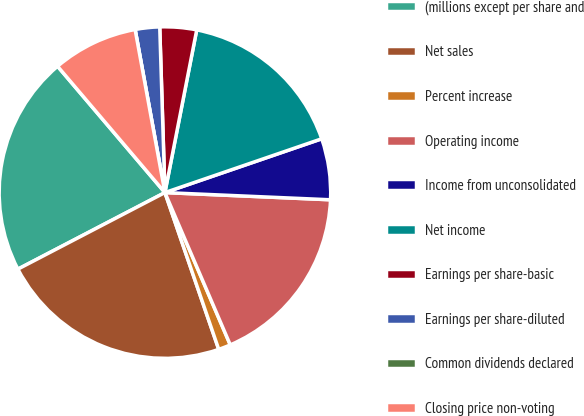Convert chart to OTSL. <chart><loc_0><loc_0><loc_500><loc_500><pie_chart><fcel>(millions except per share and<fcel>Net sales<fcel>Percent increase<fcel>Operating income<fcel>Income from unconsolidated<fcel>Net income<fcel>Earnings per share-basic<fcel>Earnings per share-diluted<fcel>Common dividends declared<fcel>Closing price non-voting<nl><fcel>21.42%<fcel>22.61%<fcel>1.19%<fcel>17.85%<fcel>5.95%<fcel>16.66%<fcel>3.57%<fcel>2.38%<fcel>0.0%<fcel>8.33%<nl></chart> 